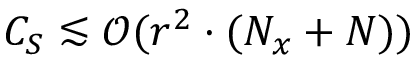<formula> <loc_0><loc_0><loc_500><loc_500>C _ { S } \lesssim \mathcal { O } ( r ^ { 2 } \cdot ( N _ { x } + N ) )</formula> 